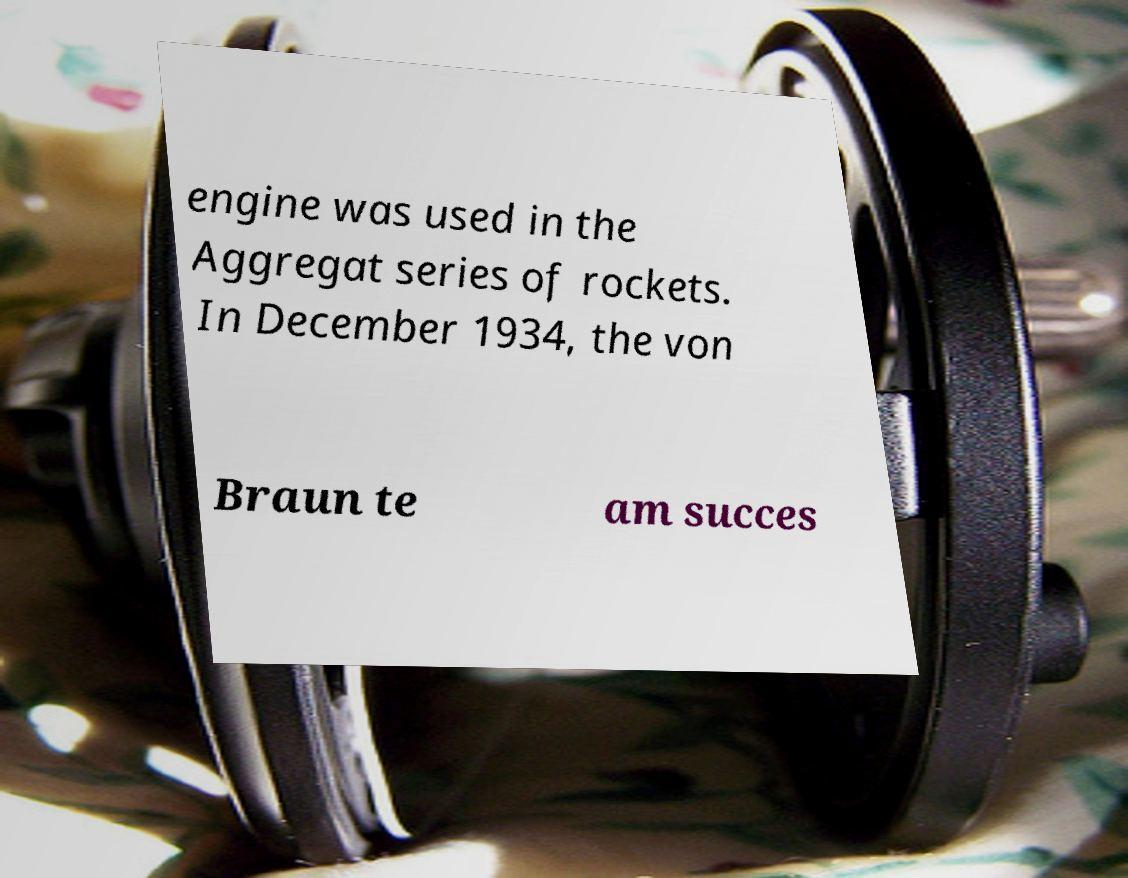I need the written content from this picture converted into text. Can you do that? engine was used in the Aggregat series of rockets. In December 1934, the von Braun te am succes 